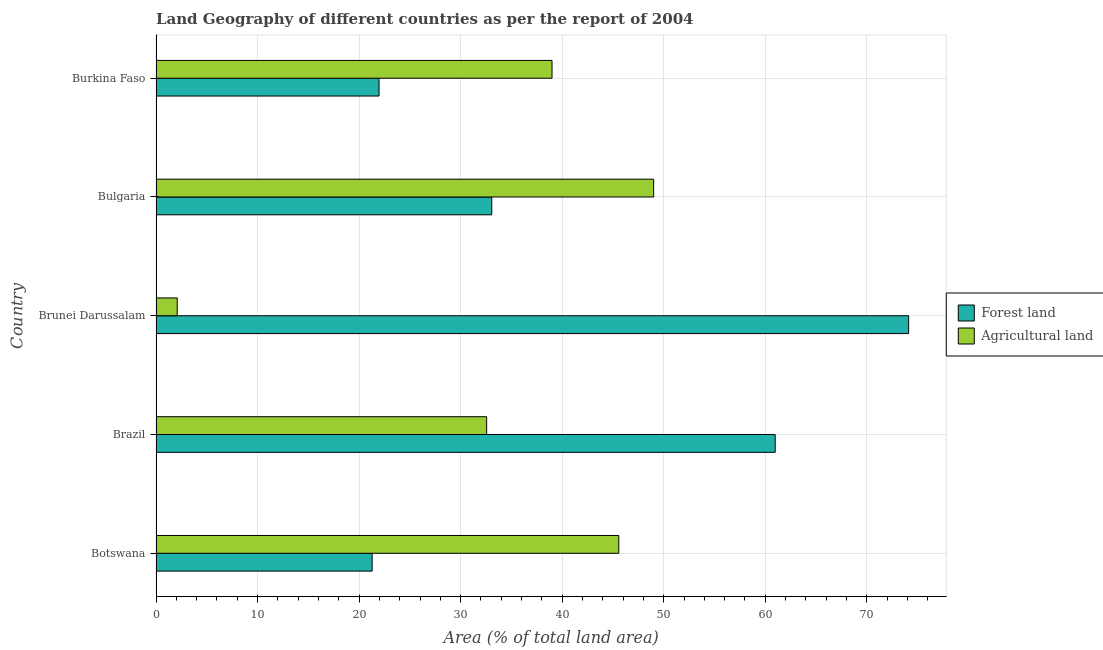How many different coloured bars are there?
Keep it short and to the point. 2. How many groups of bars are there?
Make the answer very short. 5. What is the label of the 1st group of bars from the top?
Provide a succinct answer. Burkina Faso. What is the percentage of land area under agriculture in Brazil?
Make the answer very short. 32.56. Across all countries, what is the maximum percentage of land area under agriculture?
Keep it short and to the point. 49.01. Across all countries, what is the minimum percentage of land area under forests?
Your answer should be very brief. 21.28. In which country was the percentage of land area under agriculture maximum?
Keep it short and to the point. Bulgaria. In which country was the percentage of land area under agriculture minimum?
Your answer should be very brief. Brunei Darussalam. What is the total percentage of land area under forests in the graph?
Provide a succinct answer. 211.4. What is the difference between the percentage of land area under agriculture in Botswana and that in Brazil?
Provide a short and direct response. 13.01. What is the difference between the percentage of land area under agriculture in Bulgaria and the percentage of land area under forests in Burkina Faso?
Provide a succinct answer. 27.04. What is the average percentage of land area under agriculture per country?
Offer a terse response. 33.65. What is the difference between the percentage of land area under agriculture and percentage of land area under forests in Brazil?
Provide a succinct answer. -28.42. What is the ratio of the percentage of land area under forests in Botswana to that in Brunei Darussalam?
Ensure brevity in your answer.  0.29. Is the percentage of land area under agriculture in Botswana less than that in Brazil?
Your answer should be very brief. No. Is the difference between the percentage of land area under forests in Brunei Darussalam and Burkina Faso greater than the difference between the percentage of land area under agriculture in Brunei Darussalam and Burkina Faso?
Provide a succinct answer. Yes. What is the difference between the highest and the second highest percentage of land area under agriculture?
Your response must be concise. 3.44. What is the difference between the highest and the lowest percentage of land area under agriculture?
Offer a very short reply. 46.92. In how many countries, is the percentage of land area under forests greater than the average percentage of land area under forests taken over all countries?
Offer a very short reply. 2. Is the sum of the percentage of land area under agriculture in Botswana and Bulgaria greater than the maximum percentage of land area under forests across all countries?
Ensure brevity in your answer.  Yes. What does the 2nd bar from the top in Brazil represents?
Your answer should be very brief. Forest land. What does the 2nd bar from the bottom in Botswana represents?
Your response must be concise. Agricultural land. How many bars are there?
Your answer should be compact. 10. How many countries are there in the graph?
Your response must be concise. 5. What is the difference between two consecutive major ticks on the X-axis?
Offer a very short reply. 10. Are the values on the major ticks of X-axis written in scientific E-notation?
Give a very brief answer. No. How many legend labels are there?
Your response must be concise. 2. How are the legend labels stacked?
Provide a short and direct response. Vertical. What is the title of the graph?
Offer a very short reply. Land Geography of different countries as per the report of 2004. What is the label or title of the X-axis?
Your response must be concise. Area (% of total land area). What is the label or title of the Y-axis?
Make the answer very short. Country. What is the Area (% of total land area) of Forest land in Botswana?
Keep it short and to the point. 21.28. What is the Area (% of total land area) of Agricultural land in Botswana?
Provide a short and direct response. 45.57. What is the Area (% of total land area) in Forest land in Brazil?
Offer a very short reply. 60.98. What is the Area (% of total land area) of Agricultural land in Brazil?
Provide a succinct answer. 32.56. What is the Area (% of total land area) of Forest land in Brunei Darussalam?
Offer a very short reply. 74.12. What is the Area (% of total land area) in Agricultural land in Brunei Darussalam?
Provide a short and direct response. 2.09. What is the Area (% of total land area) in Forest land in Bulgaria?
Offer a terse response. 33.06. What is the Area (% of total land area) in Agricultural land in Bulgaria?
Offer a very short reply. 49.01. What is the Area (% of total land area) of Forest land in Burkina Faso?
Ensure brevity in your answer.  21.96. What is the Area (% of total land area) in Agricultural land in Burkina Faso?
Provide a short and direct response. 39. Across all countries, what is the maximum Area (% of total land area) in Forest land?
Your response must be concise. 74.12. Across all countries, what is the maximum Area (% of total land area) in Agricultural land?
Your response must be concise. 49.01. Across all countries, what is the minimum Area (% of total land area) of Forest land?
Your answer should be compact. 21.28. Across all countries, what is the minimum Area (% of total land area) of Agricultural land?
Provide a short and direct response. 2.09. What is the total Area (% of total land area) of Forest land in the graph?
Offer a very short reply. 211.4. What is the total Area (% of total land area) of Agricultural land in the graph?
Offer a terse response. 168.22. What is the difference between the Area (% of total land area) in Forest land in Botswana and that in Brazil?
Offer a terse response. -39.69. What is the difference between the Area (% of total land area) of Agricultural land in Botswana and that in Brazil?
Provide a short and direct response. 13.01. What is the difference between the Area (% of total land area) in Forest land in Botswana and that in Brunei Darussalam?
Keep it short and to the point. -52.84. What is the difference between the Area (% of total land area) in Agricultural land in Botswana and that in Brunei Darussalam?
Give a very brief answer. 43.48. What is the difference between the Area (% of total land area) of Forest land in Botswana and that in Bulgaria?
Provide a succinct answer. -11.78. What is the difference between the Area (% of total land area) of Agricultural land in Botswana and that in Bulgaria?
Offer a terse response. -3.44. What is the difference between the Area (% of total land area) in Forest land in Botswana and that in Burkina Faso?
Ensure brevity in your answer.  -0.68. What is the difference between the Area (% of total land area) in Agricultural land in Botswana and that in Burkina Faso?
Keep it short and to the point. 6.57. What is the difference between the Area (% of total land area) in Forest land in Brazil and that in Brunei Darussalam?
Give a very brief answer. -13.14. What is the difference between the Area (% of total land area) of Agricultural land in Brazil and that in Brunei Darussalam?
Your response must be concise. 30.47. What is the difference between the Area (% of total land area) in Forest land in Brazil and that in Bulgaria?
Your answer should be compact. 27.91. What is the difference between the Area (% of total land area) in Agricultural land in Brazil and that in Bulgaria?
Provide a succinct answer. -16.45. What is the difference between the Area (% of total land area) in Forest land in Brazil and that in Burkina Faso?
Offer a very short reply. 39.01. What is the difference between the Area (% of total land area) in Agricultural land in Brazil and that in Burkina Faso?
Your response must be concise. -6.44. What is the difference between the Area (% of total land area) in Forest land in Brunei Darussalam and that in Bulgaria?
Make the answer very short. 41.06. What is the difference between the Area (% of total land area) in Agricultural land in Brunei Darussalam and that in Bulgaria?
Offer a terse response. -46.92. What is the difference between the Area (% of total land area) in Forest land in Brunei Darussalam and that in Burkina Faso?
Your answer should be compact. 52.16. What is the difference between the Area (% of total land area) in Agricultural land in Brunei Darussalam and that in Burkina Faso?
Provide a short and direct response. -36.91. What is the difference between the Area (% of total land area) of Forest land in Bulgaria and that in Burkina Faso?
Provide a succinct answer. 11.1. What is the difference between the Area (% of total land area) of Agricultural land in Bulgaria and that in Burkina Faso?
Offer a very short reply. 10.01. What is the difference between the Area (% of total land area) in Forest land in Botswana and the Area (% of total land area) in Agricultural land in Brazil?
Provide a succinct answer. -11.28. What is the difference between the Area (% of total land area) in Forest land in Botswana and the Area (% of total land area) in Agricultural land in Brunei Darussalam?
Offer a very short reply. 19.2. What is the difference between the Area (% of total land area) of Forest land in Botswana and the Area (% of total land area) of Agricultural land in Bulgaria?
Provide a succinct answer. -27.72. What is the difference between the Area (% of total land area) of Forest land in Botswana and the Area (% of total land area) of Agricultural land in Burkina Faso?
Provide a short and direct response. -17.72. What is the difference between the Area (% of total land area) of Forest land in Brazil and the Area (% of total land area) of Agricultural land in Brunei Darussalam?
Your response must be concise. 58.89. What is the difference between the Area (% of total land area) of Forest land in Brazil and the Area (% of total land area) of Agricultural land in Bulgaria?
Your answer should be compact. 11.97. What is the difference between the Area (% of total land area) of Forest land in Brazil and the Area (% of total land area) of Agricultural land in Burkina Faso?
Ensure brevity in your answer.  21.98. What is the difference between the Area (% of total land area) in Forest land in Brunei Darussalam and the Area (% of total land area) in Agricultural land in Bulgaria?
Provide a succinct answer. 25.11. What is the difference between the Area (% of total land area) in Forest land in Brunei Darussalam and the Area (% of total land area) in Agricultural land in Burkina Faso?
Provide a succinct answer. 35.12. What is the difference between the Area (% of total land area) in Forest land in Bulgaria and the Area (% of total land area) in Agricultural land in Burkina Faso?
Make the answer very short. -5.94. What is the average Area (% of total land area) in Forest land per country?
Offer a very short reply. 42.28. What is the average Area (% of total land area) in Agricultural land per country?
Your response must be concise. 33.64. What is the difference between the Area (% of total land area) of Forest land and Area (% of total land area) of Agricultural land in Botswana?
Offer a terse response. -24.29. What is the difference between the Area (% of total land area) of Forest land and Area (% of total land area) of Agricultural land in Brazil?
Offer a terse response. 28.42. What is the difference between the Area (% of total land area) of Forest land and Area (% of total land area) of Agricultural land in Brunei Darussalam?
Your answer should be compact. 72.03. What is the difference between the Area (% of total land area) in Forest land and Area (% of total land area) in Agricultural land in Bulgaria?
Your answer should be compact. -15.95. What is the difference between the Area (% of total land area) of Forest land and Area (% of total land area) of Agricultural land in Burkina Faso?
Give a very brief answer. -17.04. What is the ratio of the Area (% of total land area) in Forest land in Botswana to that in Brazil?
Ensure brevity in your answer.  0.35. What is the ratio of the Area (% of total land area) of Agricultural land in Botswana to that in Brazil?
Offer a very short reply. 1.4. What is the ratio of the Area (% of total land area) in Forest land in Botswana to that in Brunei Darussalam?
Keep it short and to the point. 0.29. What is the ratio of the Area (% of total land area) of Agricultural land in Botswana to that in Brunei Darussalam?
Offer a very short reply. 21.83. What is the ratio of the Area (% of total land area) of Forest land in Botswana to that in Bulgaria?
Your answer should be compact. 0.64. What is the ratio of the Area (% of total land area) in Agricultural land in Botswana to that in Bulgaria?
Provide a short and direct response. 0.93. What is the ratio of the Area (% of total land area) in Forest land in Botswana to that in Burkina Faso?
Keep it short and to the point. 0.97. What is the ratio of the Area (% of total land area) in Agricultural land in Botswana to that in Burkina Faso?
Your answer should be very brief. 1.17. What is the ratio of the Area (% of total land area) of Forest land in Brazil to that in Brunei Darussalam?
Offer a terse response. 0.82. What is the ratio of the Area (% of total land area) of Agricultural land in Brazil to that in Brunei Darussalam?
Ensure brevity in your answer.  15.6. What is the ratio of the Area (% of total land area) in Forest land in Brazil to that in Bulgaria?
Your answer should be very brief. 1.84. What is the ratio of the Area (% of total land area) in Agricultural land in Brazil to that in Bulgaria?
Provide a succinct answer. 0.66. What is the ratio of the Area (% of total land area) in Forest land in Brazil to that in Burkina Faso?
Offer a very short reply. 2.78. What is the ratio of the Area (% of total land area) of Agricultural land in Brazil to that in Burkina Faso?
Your response must be concise. 0.83. What is the ratio of the Area (% of total land area) in Forest land in Brunei Darussalam to that in Bulgaria?
Your answer should be very brief. 2.24. What is the ratio of the Area (% of total land area) in Agricultural land in Brunei Darussalam to that in Bulgaria?
Your response must be concise. 0.04. What is the ratio of the Area (% of total land area) in Forest land in Brunei Darussalam to that in Burkina Faso?
Ensure brevity in your answer.  3.37. What is the ratio of the Area (% of total land area) in Agricultural land in Brunei Darussalam to that in Burkina Faso?
Keep it short and to the point. 0.05. What is the ratio of the Area (% of total land area) of Forest land in Bulgaria to that in Burkina Faso?
Your answer should be very brief. 1.51. What is the ratio of the Area (% of total land area) of Agricultural land in Bulgaria to that in Burkina Faso?
Offer a very short reply. 1.26. What is the difference between the highest and the second highest Area (% of total land area) in Forest land?
Provide a succinct answer. 13.14. What is the difference between the highest and the second highest Area (% of total land area) of Agricultural land?
Keep it short and to the point. 3.44. What is the difference between the highest and the lowest Area (% of total land area) of Forest land?
Your response must be concise. 52.84. What is the difference between the highest and the lowest Area (% of total land area) of Agricultural land?
Your answer should be compact. 46.92. 